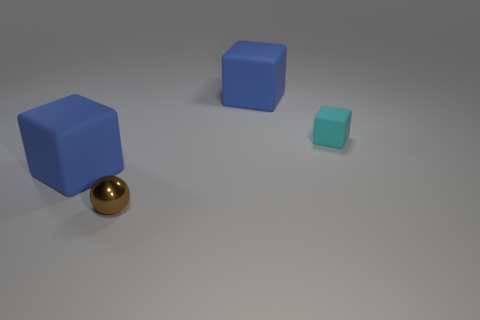Is there another small metal object of the same color as the metallic thing?
Provide a short and direct response. No. What number of other things are the same shape as the cyan matte thing?
Provide a succinct answer. 2. There is a big rubber object to the right of the brown object; what is its shape?
Provide a short and direct response. Cube. Is the shape of the brown thing the same as the matte object that is on the left side of the brown metallic object?
Provide a succinct answer. No. What size is the thing that is both behind the brown sphere and in front of the small cyan cube?
Give a very brief answer. Large. The matte object that is both left of the small matte block and right of the shiny thing is what color?
Provide a short and direct response. Blue. Are there any other things that are the same material as the tiny cyan block?
Provide a short and direct response. Yes. Is the number of small cyan objects in front of the sphere less than the number of large rubber things right of the cyan cube?
Offer a terse response. No. Are there any other things that have the same color as the small block?
Ensure brevity in your answer.  No. What is the shape of the shiny object?
Offer a very short reply. Sphere. 